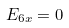<formula> <loc_0><loc_0><loc_500><loc_500>E _ { 6 x } = 0</formula> 